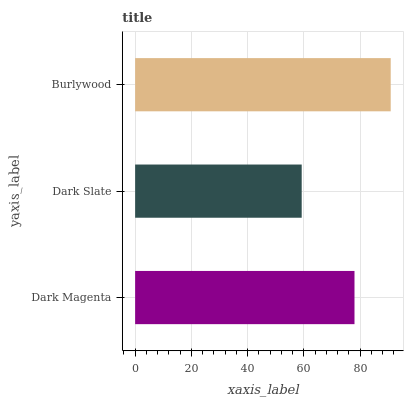Is Dark Slate the minimum?
Answer yes or no. Yes. Is Burlywood the maximum?
Answer yes or no. Yes. Is Burlywood the minimum?
Answer yes or no. No. Is Dark Slate the maximum?
Answer yes or no. No. Is Burlywood greater than Dark Slate?
Answer yes or no. Yes. Is Dark Slate less than Burlywood?
Answer yes or no. Yes. Is Dark Slate greater than Burlywood?
Answer yes or no. No. Is Burlywood less than Dark Slate?
Answer yes or no. No. Is Dark Magenta the high median?
Answer yes or no. Yes. Is Dark Magenta the low median?
Answer yes or no. Yes. Is Burlywood the high median?
Answer yes or no. No. Is Dark Slate the low median?
Answer yes or no. No. 